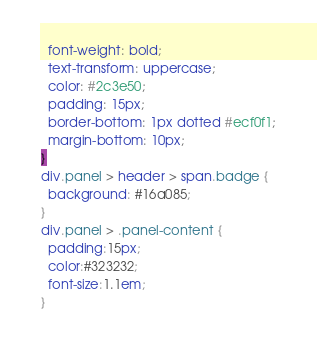Convert code to text. <code><loc_0><loc_0><loc_500><loc_500><_CSS_>  font-weight: bold;
  text-transform: uppercase;
  color: #2c3e50;
  padding: 15px;
  border-bottom: 1px dotted #ecf0f1;
  margin-bottom: 10px;
}
div.panel > header > span.badge {
  background: #16a085;
}
div.panel > .panel-content {
  padding:15px;
  color:#323232;
  font-size:1.1em;
}</code> 